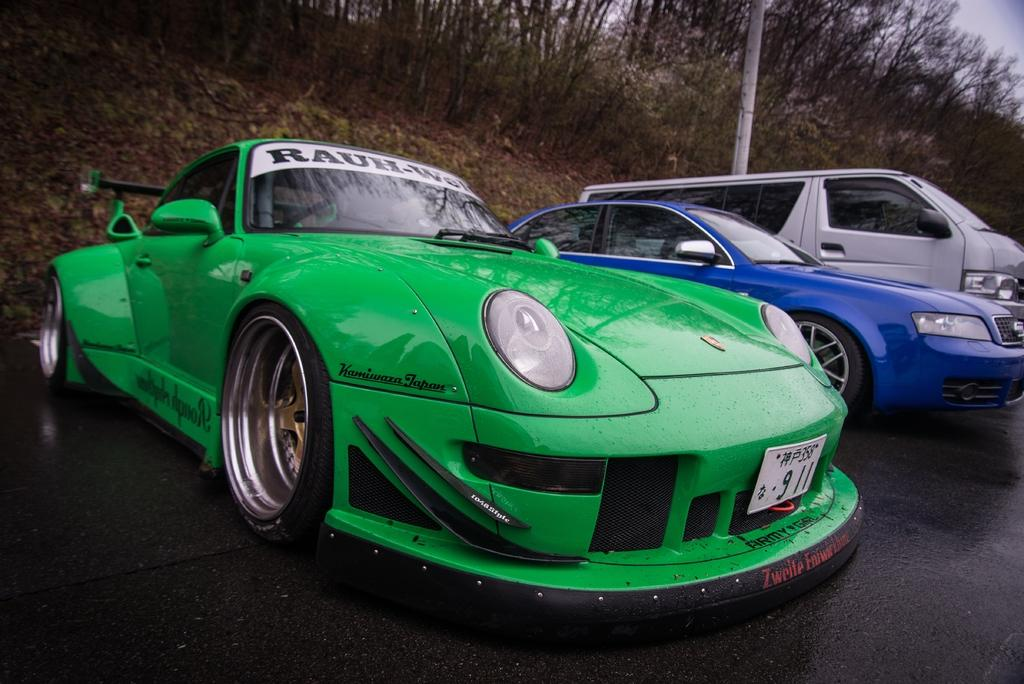What can be seen in the foreground of the picture? There are cars parked on the road in the foreground of the picture. What is visible in the background of the picture? There are trees in the background of the picture. What is located in the center of the picture? There is a pole in the center of the picture, along with dry leaves and soil. What is your sister's rate of thrill while driving one of the cars in the picture? There is no information about a sister or her driving habits in the image, so we cannot answer this question. 